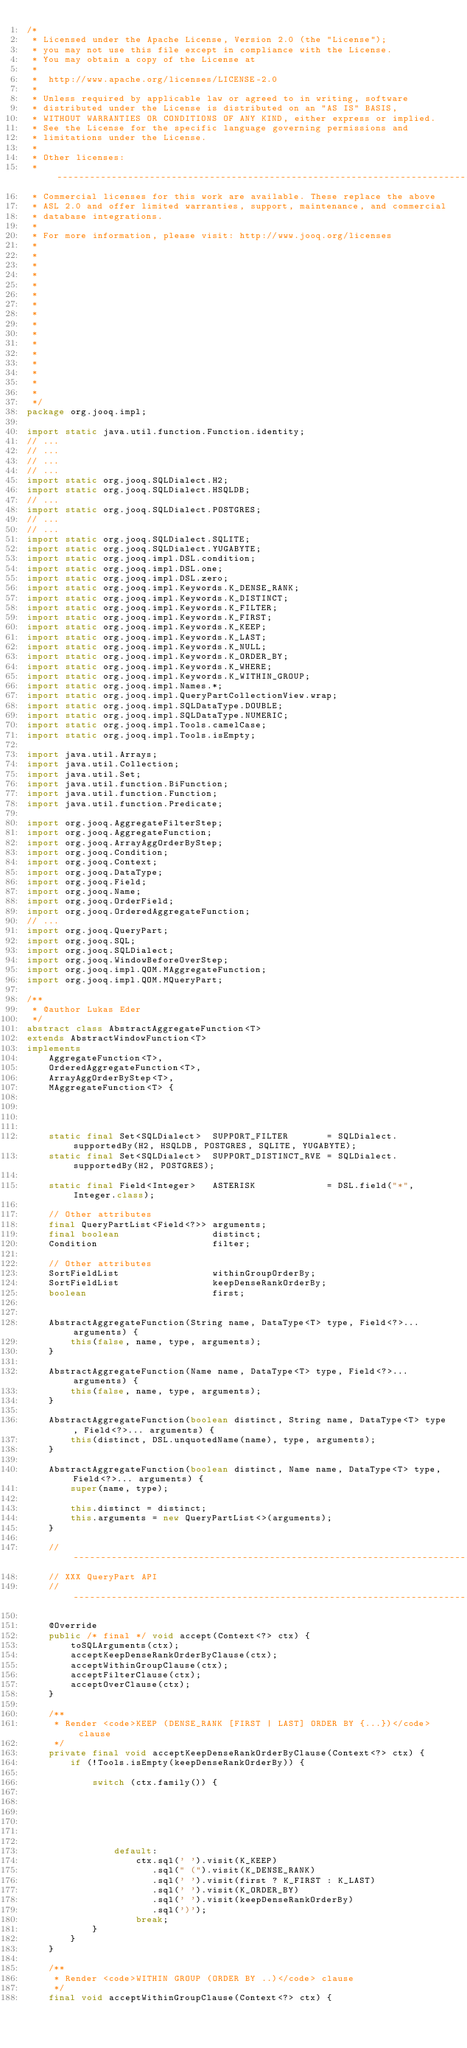<code> <loc_0><loc_0><loc_500><loc_500><_Java_>/*
 * Licensed under the Apache License, Version 2.0 (the "License");
 * you may not use this file except in compliance with the License.
 * You may obtain a copy of the License at
 *
 *  http://www.apache.org/licenses/LICENSE-2.0
 *
 * Unless required by applicable law or agreed to in writing, software
 * distributed under the License is distributed on an "AS IS" BASIS,
 * WITHOUT WARRANTIES OR CONDITIONS OF ANY KIND, either express or implied.
 * See the License for the specific language governing permissions and
 * limitations under the License.
 *
 * Other licenses:
 * -----------------------------------------------------------------------------
 * Commercial licenses for this work are available. These replace the above
 * ASL 2.0 and offer limited warranties, support, maintenance, and commercial
 * database integrations.
 *
 * For more information, please visit: http://www.jooq.org/licenses
 *
 *
 *
 *
 *
 *
 *
 *
 *
 *
 *
 *
 *
 *
 *
 *
 */
package org.jooq.impl;

import static java.util.function.Function.identity;
// ...
// ...
// ...
// ...
import static org.jooq.SQLDialect.H2;
import static org.jooq.SQLDialect.HSQLDB;
// ...
import static org.jooq.SQLDialect.POSTGRES;
// ...
// ...
import static org.jooq.SQLDialect.SQLITE;
import static org.jooq.SQLDialect.YUGABYTE;
import static org.jooq.impl.DSL.condition;
import static org.jooq.impl.DSL.one;
import static org.jooq.impl.DSL.zero;
import static org.jooq.impl.Keywords.K_DENSE_RANK;
import static org.jooq.impl.Keywords.K_DISTINCT;
import static org.jooq.impl.Keywords.K_FILTER;
import static org.jooq.impl.Keywords.K_FIRST;
import static org.jooq.impl.Keywords.K_KEEP;
import static org.jooq.impl.Keywords.K_LAST;
import static org.jooq.impl.Keywords.K_NULL;
import static org.jooq.impl.Keywords.K_ORDER_BY;
import static org.jooq.impl.Keywords.K_WHERE;
import static org.jooq.impl.Keywords.K_WITHIN_GROUP;
import static org.jooq.impl.Names.*;
import static org.jooq.impl.QueryPartCollectionView.wrap;
import static org.jooq.impl.SQLDataType.DOUBLE;
import static org.jooq.impl.SQLDataType.NUMERIC;
import static org.jooq.impl.Tools.camelCase;
import static org.jooq.impl.Tools.isEmpty;

import java.util.Arrays;
import java.util.Collection;
import java.util.Set;
import java.util.function.BiFunction;
import java.util.function.Function;
import java.util.function.Predicate;

import org.jooq.AggregateFilterStep;
import org.jooq.AggregateFunction;
import org.jooq.ArrayAggOrderByStep;
import org.jooq.Condition;
import org.jooq.Context;
import org.jooq.DataType;
import org.jooq.Field;
import org.jooq.Name;
import org.jooq.OrderField;
import org.jooq.OrderedAggregateFunction;
// ...
import org.jooq.QueryPart;
import org.jooq.SQL;
import org.jooq.SQLDialect;
import org.jooq.WindowBeforeOverStep;
import org.jooq.impl.QOM.MAggregateFunction;
import org.jooq.impl.QOM.MQueryPart;

/**
 * @author Lukas Eder
 */
abstract class AbstractAggregateFunction<T>
extends AbstractWindowFunction<T>
implements
    AggregateFunction<T>,
    OrderedAggregateFunction<T>,
    ArrayAggOrderByStep<T>,
    MAggregateFunction<T> {




    static final Set<SQLDialect>  SUPPORT_FILTER       = SQLDialect.supportedBy(H2, HSQLDB, POSTGRES, SQLITE, YUGABYTE);
    static final Set<SQLDialect>  SUPPORT_DISTINCT_RVE = SQLDialect.supportedBy(H2, POSTGRES);

    static final Field<Integer>   ASTERISK             = DSL.field("*", Integer.class);

    // Other attributes
    final QueryPartList<Field<?>> arguments;
    final boolean                 distinct;
    Condition                     filter;

    // Other attributes
    SortFieldList                 withinGroupOrderBy;
    SortFieldList                 keepDenseRankOrderBy;
    boolean                       first;


    AbstractAggregateFunction(String name, DataType<T> type, Field<?>... arguments) {
        this(false, name, type, arguments);
    }

    AbstractAggregateFunction(Name name, DataType<T> type, Field<?>... arguments) {
        this(false, name, type, arguments);
    }

    AbstractAggregateFunction(boolean distinct, String name, DataType<T> type, Field<?>... arguments) {
        this(distinct, DSL.unquotedName(name), type, arguments);
    }

    AbstractAggregateFunction(boolean distinct, Name name, DataType<T> type, Field<?>... arguments) {
        super(name, type);

        this.distinct = distinct;
        this.arguments = new QueryPartList<>(arguments);
    }

    // -------------------------------------------------------------------------
    // XXX QueryPart API
    // -------------------------------------------------------------------------

    @Override
    public /* final */ void accept(Context<?> ctx) {
        toSQLArguments(ctx);
        acceptKeepDenseRankOrderByClause(ctx);
        acceptWithinGroupClause(ctx);
        acceptFilterClause(ctx);
        acceptOverClause(ctx);
    }

    /**
     * Render <code>KEEP (DENSE_RANK [FIRST | LAST] ORDER BY {...})</code> clause
     */
    private final void acceptKeepDenseRankOrderByClause(Context<?> ctx) {
        if (!Tools.isEmpty(keepDenseRankOrderBy)) {

            switch (ctx.family()) {






                default:
                    ctx.sql(' ').visit(K_KEEP)
                       .sql(" (").visit(K_DENSE_RANK)
                       .sql(' ').visit(first ? K_FIRST : K_LAST)
                       .sql(' ').visit(K_ORDER_BY)
                       .sql(' ').visit(keepDenseRankOrderBy)
                       .sql(')');
                    break;
            }
        }
    }

    /**
     * Render <code>WITHIN GROUP (ORDER BY ..)</code> clause
     */
    final void acceptWithinGroupClause(Context<?> ctx) {</code> 